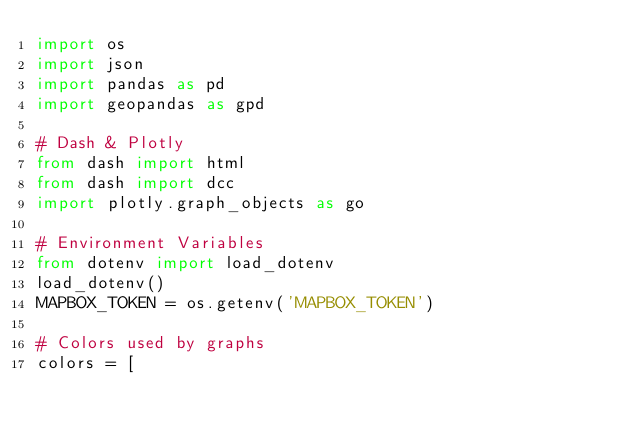Convert code to text. <code><loc_0><loc_0><loc_500><loc_500><_Python_>import os
import json
import pandas as pd
import geopandas as gpd

# Dash & Plotly
from dash import html
from dash import dcc
import plotly.graph_objects as go

# Environment Variables
from dotenv import load_dotenv
load_dotenv()
MAPBOX_TOKEN = os.getenv('MAPBOX_TOKEN')

# Colors used by graphs
colors = [</code> 